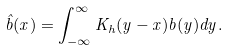Convert formula to latex. <formula><loc_0><loc_0><loc_500><loc_500>\hat { b } ( x ) = \int _ { - \infty } ^ { \infty } K _ { h } ( y - x ) b ( y ) d y .</formula> 